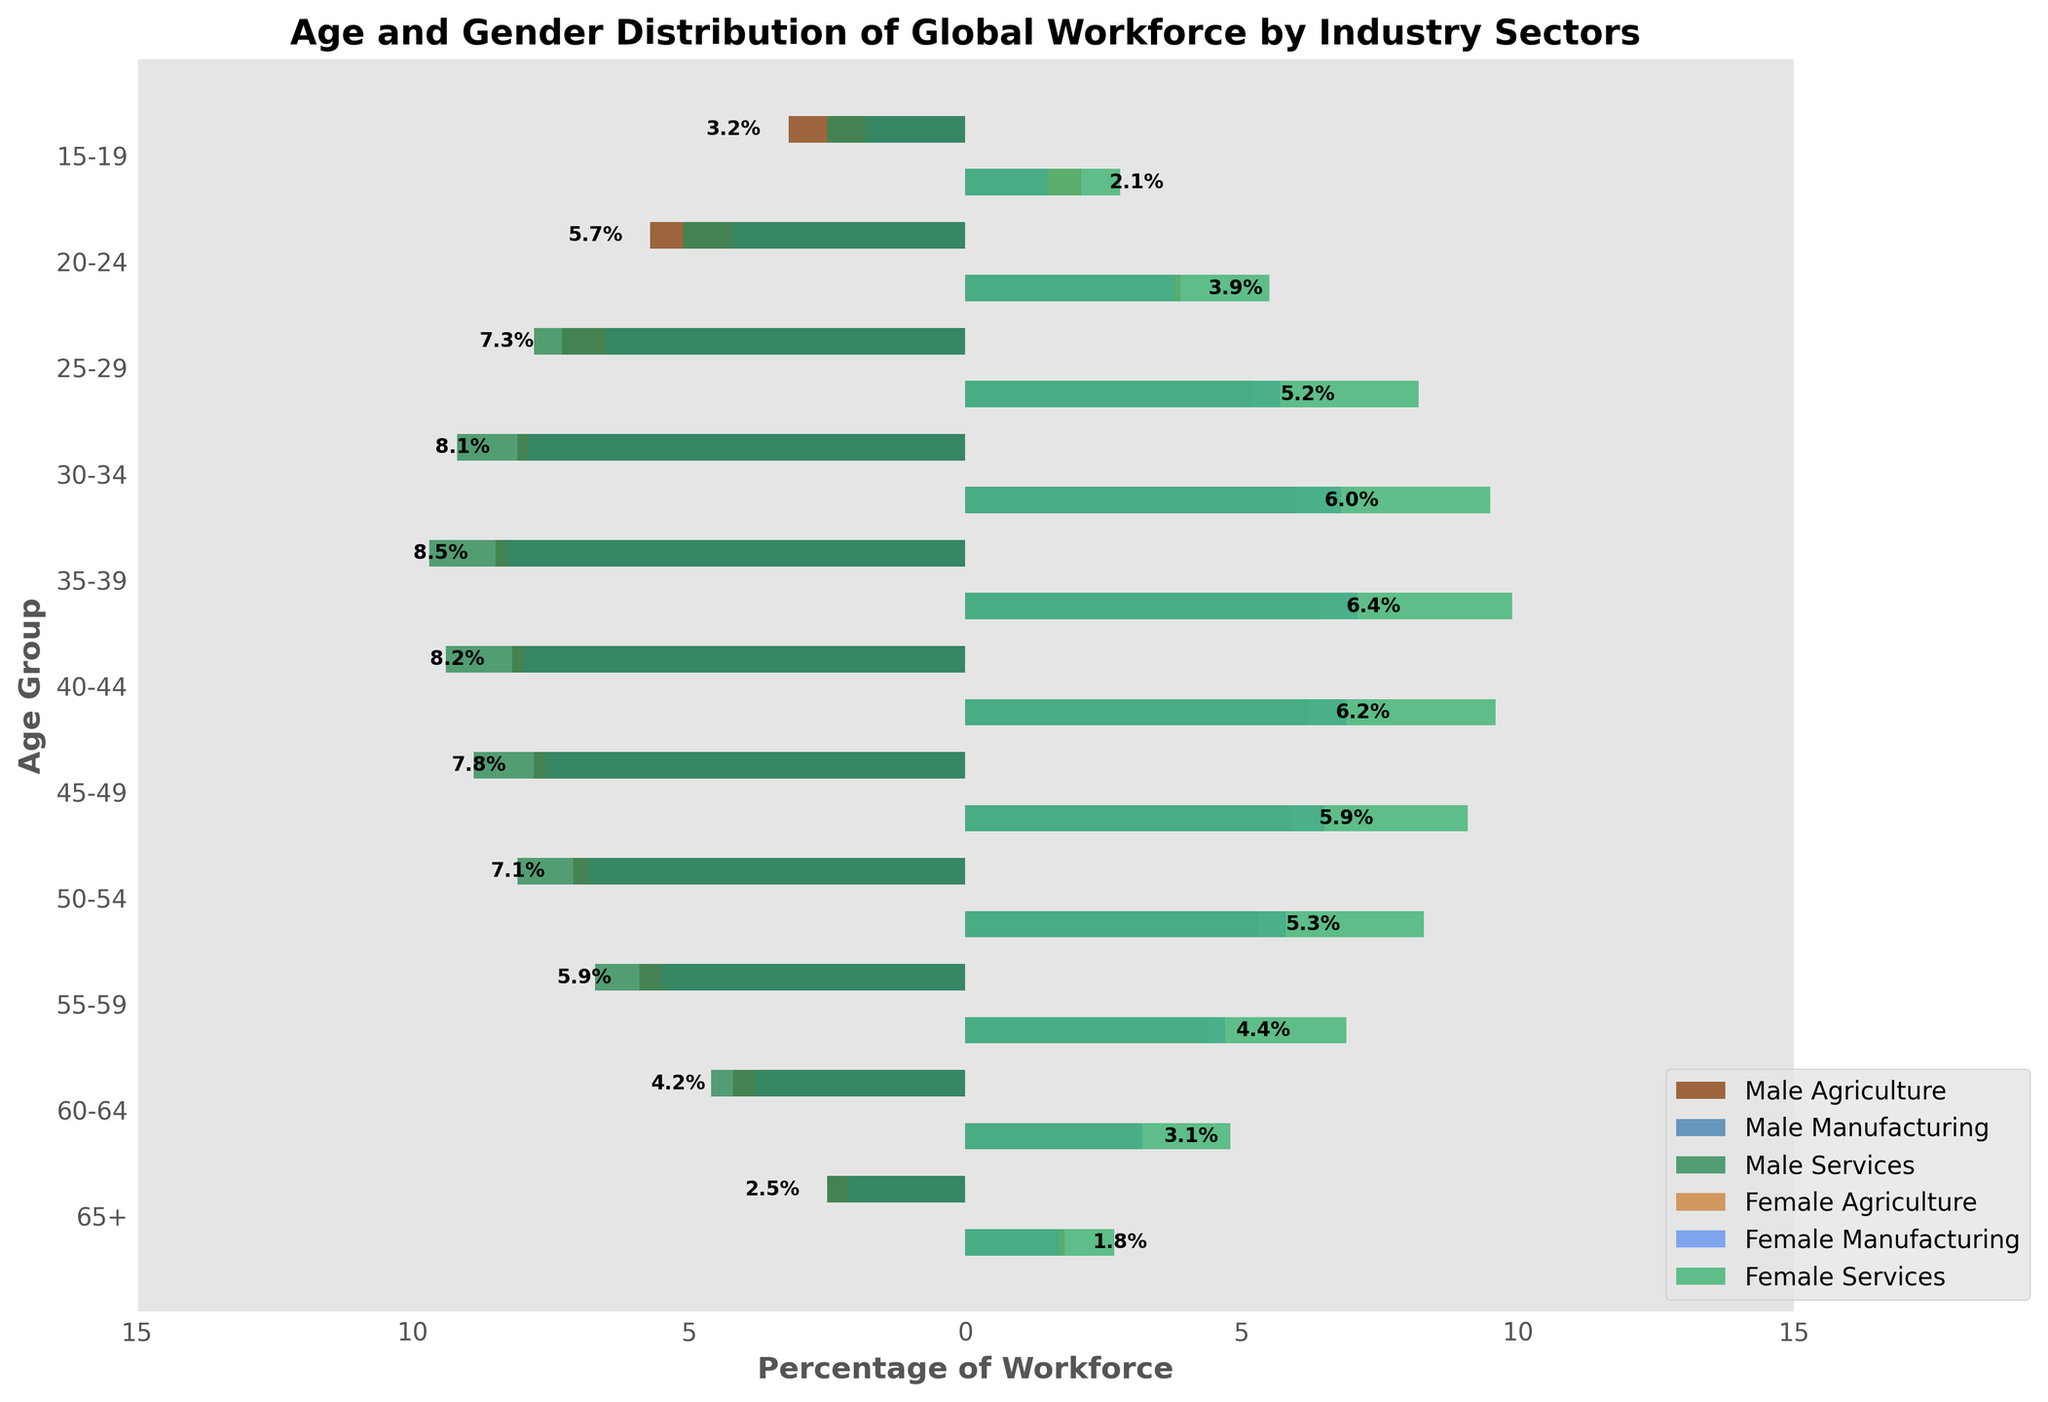What is the title of the figure? The title of the figure is usually placed at the top center of the chart and describes what the figure is representing. In this case, it tells about the age and gender distribution of the global workforce by industry sectors.
Answer: Age and Gender Distribution of Global Workforce by Industry Sectors Which age group has the highest percentage of males in agriculture? To find this, one needs to look at the left side of the chart (which represents the male workforce in agriculture with negative values) and identify the age group with the longest bar in this section.
Answer: 35-39 What percentage of the workforce is represented by females aged 25-29 in services? To find this, locate the ‘25-29’ age group on the y-axis, and find the corresponding bar on the right side for female services, represented by a specific color. The length of this bar indicates the percentage.
Answer: 8.2% Compare the percentage of males and females in manufacturing for the age group 30-34. Which gender has a higher percentage? Locate the age group ‘30-34’ on the y-axis, and compare the lengths of the corresponding bars for male and female manufacturing on both sides of the pyramid to determine which bar is longer.
Answer: Males Which age group contributes the least to the workforce in services for both males and females? To determine this, look at the lengths of the bars for services at different age groups and find the age group with the shortest bars for both males and females on the left and right sides of the pyramid.
Answer: 65+ What is the difference in the percentage of males in agriculture between age groups 50-54 and 55-59? Find the bars corresponding to males in agriculture for the age groups 50-54 and 55-59. Subtract the percentage of the younger age group from the older age group to find the difference.
Answer: 1.2% How does the distribution of the male workforce in services for the age group 40-44 compare with that of females in the same sector and age group? Identify the bars for males and females in the services sector for the age group 40-44 and compare their lengths.
Answer: Slightly lower Identify the age group with an equal percentage of male and female workforce in any sector. Look closely at the bars for age groups across all sectors and find a pair of bars with equal lengths on both sides of the pyramid. Specifically for the provided data, this happens when one gender in a particular sector is close to the other gender in the same sector or another.
Answer: 65+ in services Which sector shows a more consistent percentage distribution across age groups for females? Evaluate the right side of the pyramid (females) across different age groups and sectors, looking for relatively similar bar lengths. Consistent percentages indicate stable workforce distribution.
Answer: Services 